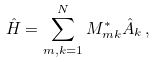Convert formula to latex. <formula><loc_0><loc_0><loc_500><loc_500>\hat { H } = \sum _ { m , k = 1 } ^ { N } M _ { m k } ^ { \ast } \hat { A } _ { k } \, ,</formula> 